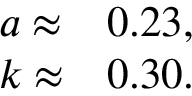Convert formula to latex. <formula><loc_0><loc_0><loc_500><loc_500>\begin{array} { l l } { a \approx } & { 0 . 2 3 , } \\ { k \approx } & { 0 . 3 0 . } \end{array}</formula> 